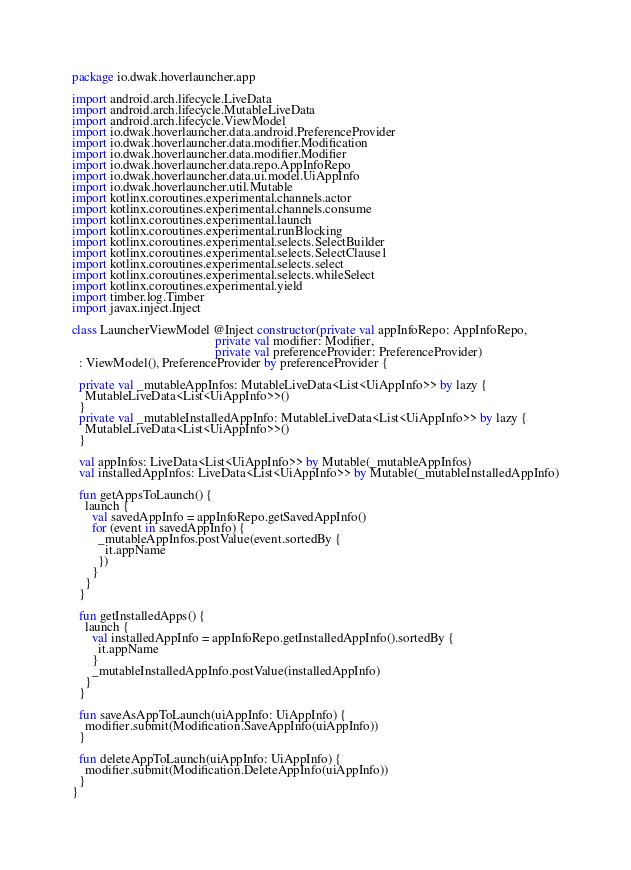<code> <loc_0><loc_0><loc_500><loc_500><_Kotlin_>package io.dwak.hoverlauncher.app

import android.arch.lifecycle.LiveData
import android.arch.lifecycle.MutableLiveData
import android.arch.lifecycle.ViewModel
import io.dwak.hoverlauncher.data.android.PreferenceProvider
import io.dwak.hoverlauncher.data.modifier.Modification
import io.dwak.hoverlauncher.data.modifier.Modifier
import io.dwak.hoverlauncher.data.repo.AppInfoRepo
import io.dwak.hoverlauncher.data.ui.model.UiAppInfo
import io.dwak.hoverlauncher.util.Mutable
import kotlinx.coroutines.experimental.channels.actor
import kotlinx.coroutines.experimental.channels.consume
import kotlinx.coroutines.experimental.launch
import kotlinx.coroutines.experimental.runBlocking
import kotlinx.coroutines.experimental.selects.SelectBuilder
import kotlinx.coroutines.experimental.selects.SelectClause1
import kotlinx.coroutines.experimental.selects.select
import kotlinx.coroutines.experimental.selects.whileSelect
import kotlinx.coroutines.experimental.yield
import timber.log.Timber
import javax.inject.Inject

class LauncherViewModel @Inject constructor(private val appInfoRepo: AppInfoRepo,
                                            private val modifier: Modifier,
                                            private val preferenceProvider: PreferenceProvider)
  : ViewModel(), PreferenceProvider by preferenceProvider {

  private val _mutableAppInfos: MutableLiveData<List<UiAppInfo>> by lazy {
    MutableLiveData<List<UiAppInfo>>()
  }
  private val _mutableInstalledAppInfo: MutableLiveData<List<UiAppInfo>> by lazy {
    MutableLiveData<List<UiAppInfo>>()
  }

  val appInfos: LiveData<List<UiAppInfo>> by Mutable(_mutableAppInfos)
  val installedAppInfos: LiveData<List<UiAppInfo>> by Mutable(_mutableInstalledAppInfo)

  fun getAppsToLaunch() {
    launch {
      val savedAppInfo = appInfoRepo.getSavedAppInfo()
      for (event in savedAppInfo) {
        _mutableAppInfos.postValue(event.sortedBy {
          it.appName
        })
      }
    }
  }

  fun getInstalledApps() {
    launch {
      val installedAppInfo = appInfoRepo.getInstalledAppInfo().sortedBy {
        it.appName
      }
      _mutableInstalledAppInfo.postValue(installedAppInfo)
    }
  }

  fun saveAsAppToLaunch(uiAppInfo: UiAppInfo) {
    modifier.submit(Modification.SaveAppInfo(uiAppInfo))
  }

  fun deleteAppToLaunch(uiAppInfo: UiAppInfo) {
    modifier.submit(Modification.DeleteAppInfo(uiAppInfo))
  }
}</code> 